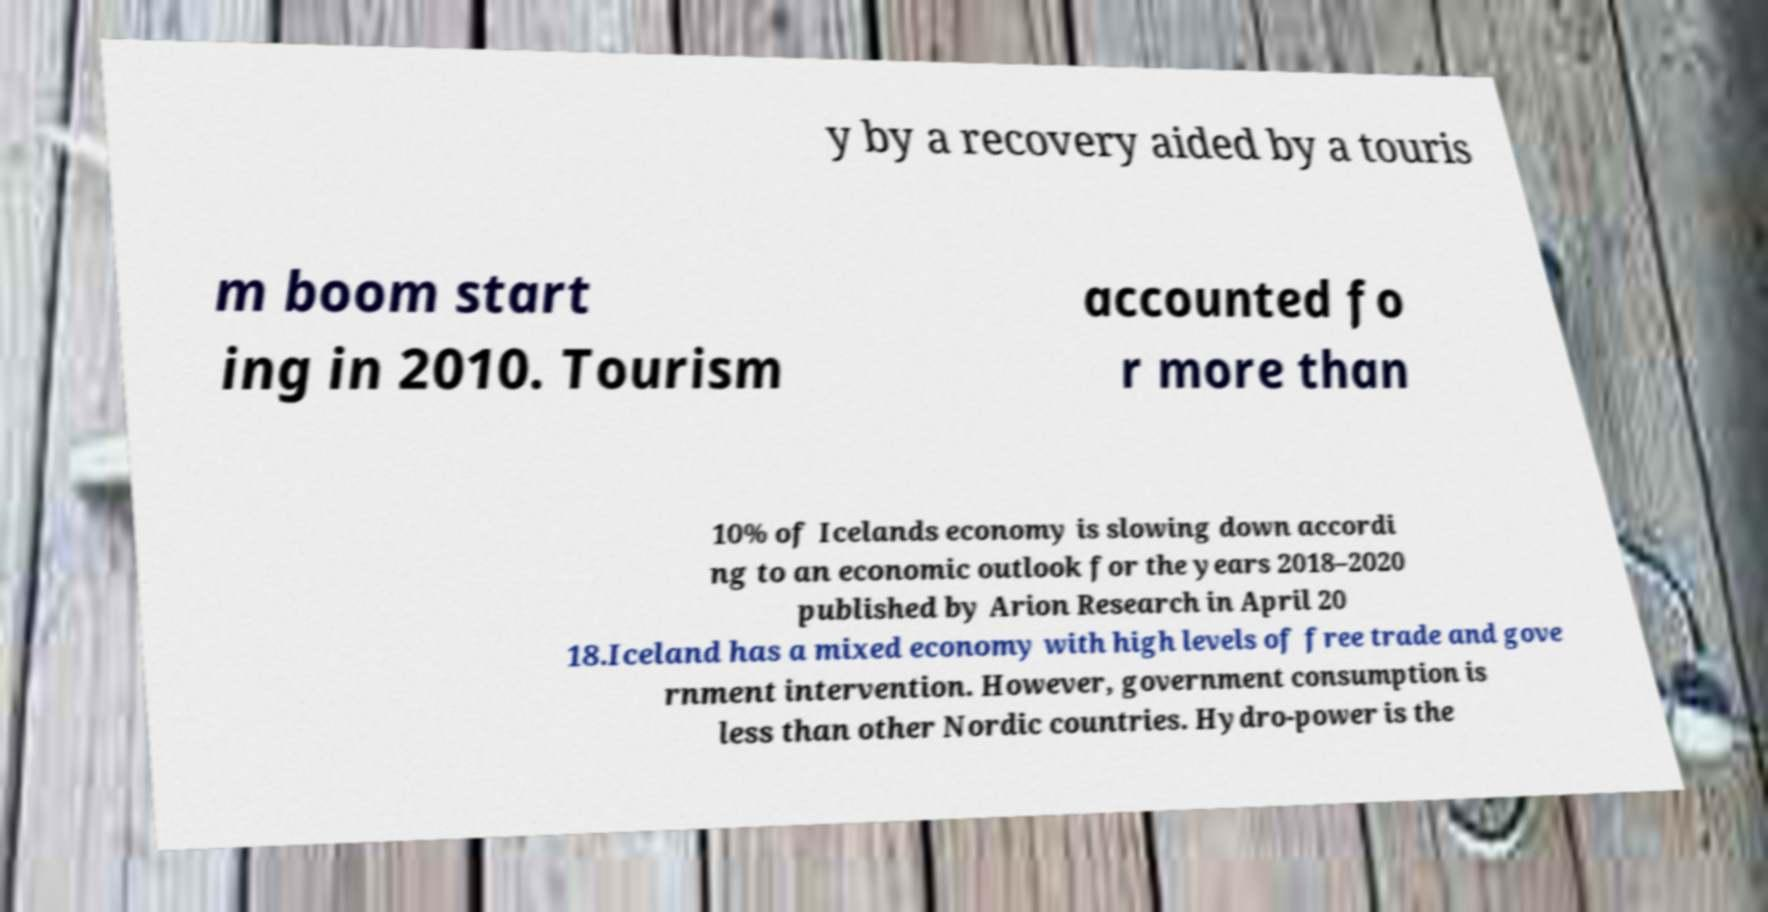Could you extract and type out the text from this image? y by a recovery aided by a touris m boom start ing in 2010. Tourism accounted fo r more than 10% of Icelands economy is slowing down accordi ng to an economic outlook for the years 2018–2020 published by Arion Research in April 20 18.Iceland has a mixed economy with high levels of free trade and gove rnment intervention. However, government consumption is less than other Nordic countries. Hydro-power is the 